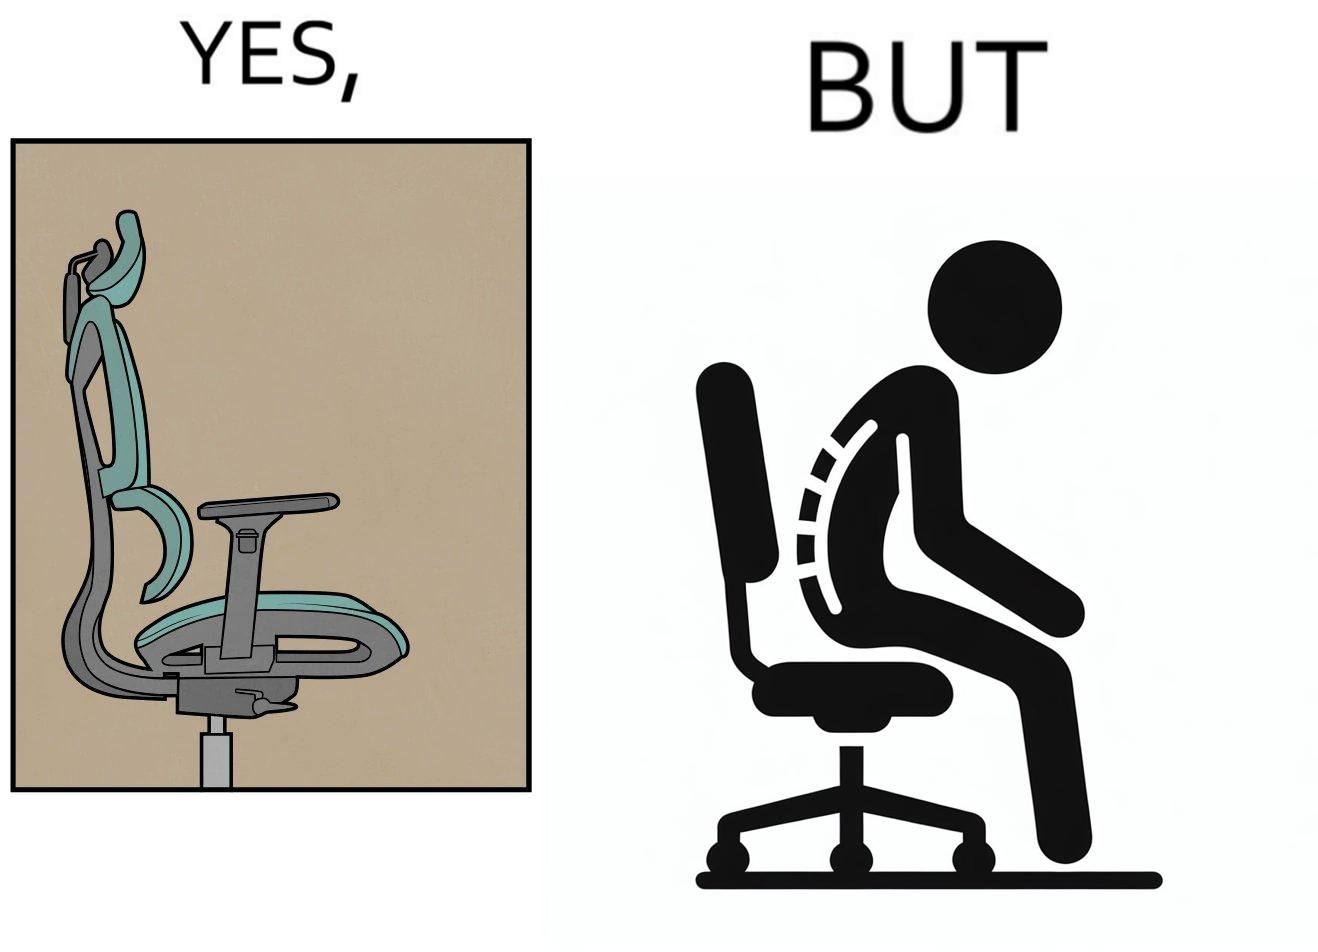What does this image depict? The image is ironical, as even though the ergonomic chair is meant to facilitate an upright and comfortable posture for the person sitting on it, the person sitting on it still has a bent posture, as the person is not utilizing the backrest. 